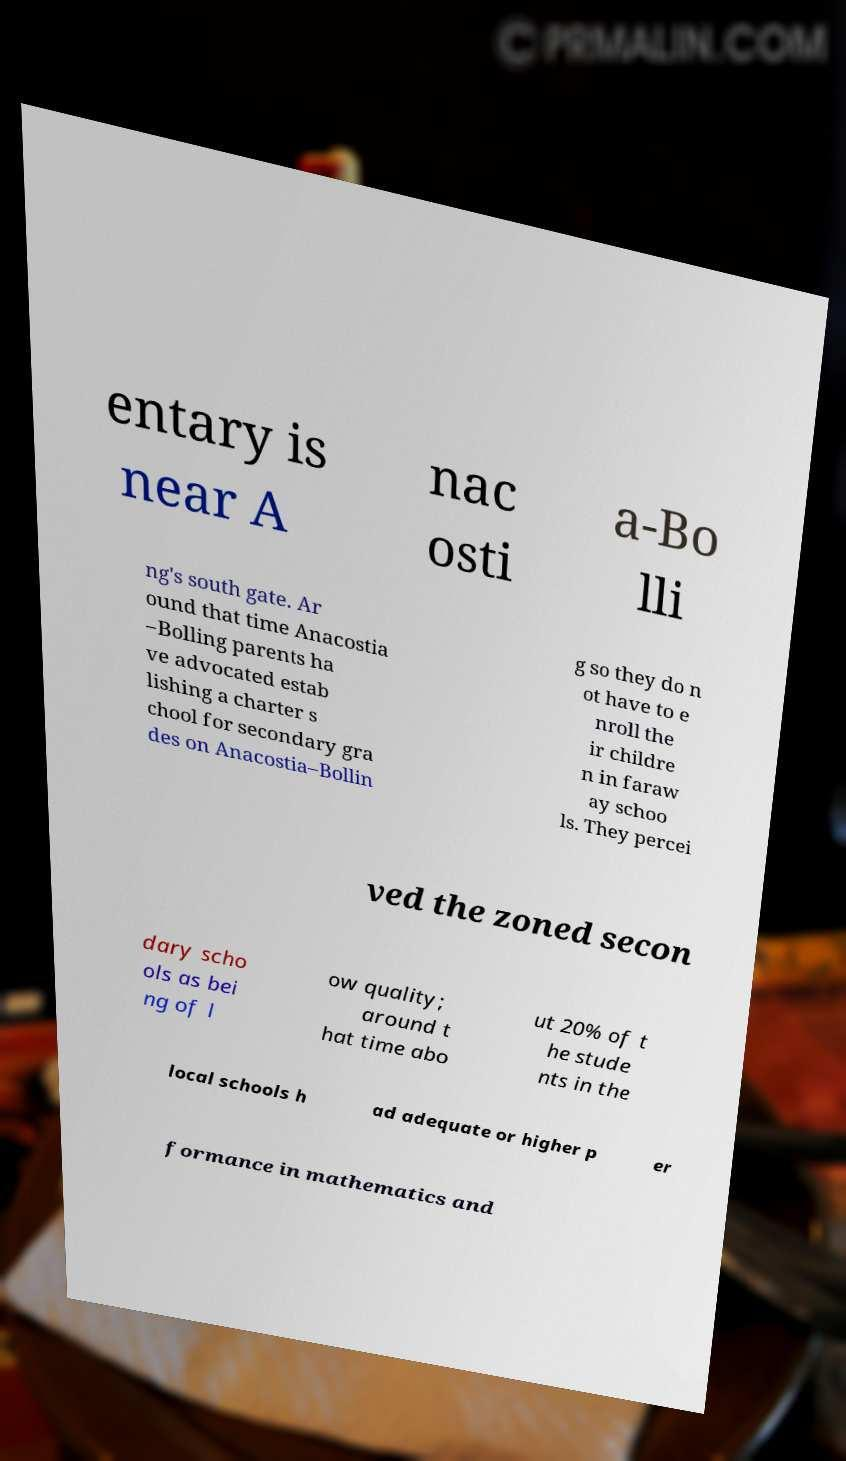For documentation purposes, I need the text within this image transcribed. Could you provide that? entary is near A nac osti a-Bo lli ng's south gate. Ar ound that time Anacostia –Bolling parents ha ve advocated estab lishing a charter s chool for secondary gra des on Anacostia–Bollin g so they do n ot have to e nroll the ir childre n in faraw ay schoo ls. They percei ved the zoned secon dary scho ols as bei ng of l ow quality; around t hat time abo ut 20% of t he stude nts in the local schools h ad adequate or higher p er formance in mathematics and 